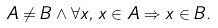<formula> <loc_0><loc_0><loc_500><loc_500>A \neq B \land \forall x , \, x \in A \Rightarrow x \in B .</formula> 